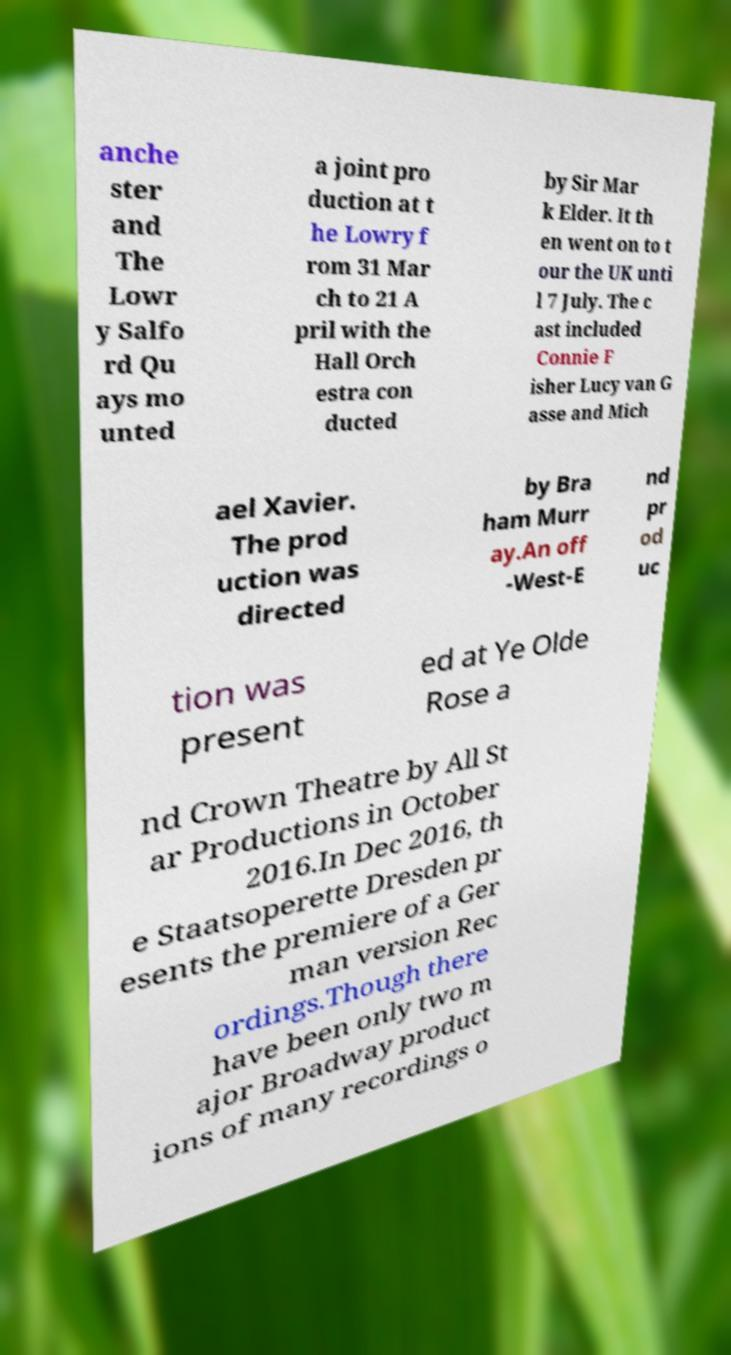Can you read and provide the text displayed in the image?This photo seems to have some interesting text. Can you extract and type it out for me? anche ster and The Lowr y Salfo rd Qu ays mo unted a joint pro duction at t he Lowry f rom 31 Mar ch to 21 A pril with the Hall Orch estra con ducted by Sir Mar k Elder. It th en went on to t our the UK unti l 7 July. The c ast included Connie F isher Lucy van G asse and Mich ael Xavier. The prod uction was directed by Bra ham Murr ay.An off -West-E nd pr od uc tion was present ed at Ye Olde Rose a nd Crown Theatre by All St ar Productions in October 2016.In Dec 2016, th e Staatsoperette Dresden pr esents the premiere of a Ger man version Rec ordings.Though there have been only two m ajor Broadway product ions of many recordings o 